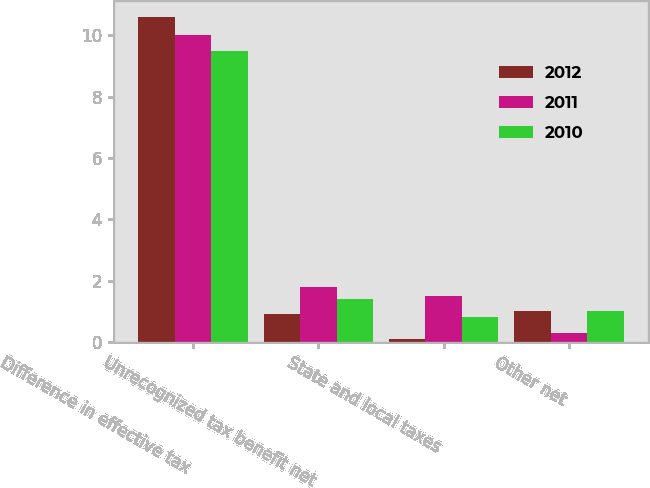Convert chart to OTSL. <chart><loc_0><loc_0><loc_500><loc_500><stacked_bar_chart><ecel><fcel>Difference in effective tax<fcel>Unrecognized tax benefit net<fcel>State and local taxes<fcel>Other net<nl><fcel>2012<fcel>10.6<fcel>0.9<fcel>0.1<fcel>1<nl><fcel>2011<fcel>10<fcel>1.8<fcel>1.5<fcel>0.3<nl><fcel>2010<fcel>9.5<fcel>1.4<fcel>0.8<fcel>1<nl></chart> 